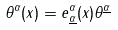Convert formula to latex. <formula><loc_0><loc_0><loc_500><loc_500>\theta ^ { \alpha } ( x ) = e ^ { \alpha } _ { \underline { \alpha } } ( x ) \theta ^ { \underline { \alpha } }</formula> 